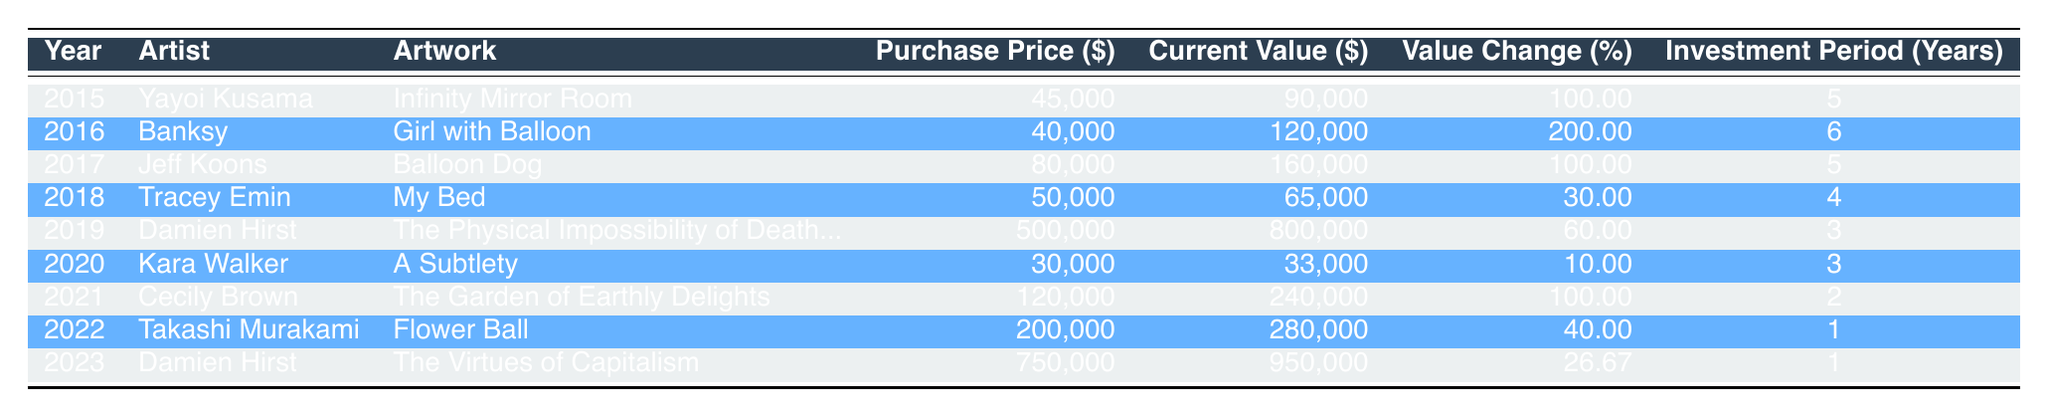What is the purchase price of the artwork "Infinity Mirror Room"? The table shows that the purchase price for "Infinity Mirror Room" by Yayoi Kusama in 2015 is 45,000. This can be found in the corresponding row under the "Purchase Price ($)" column.
Answer: 45,000 What is the current value of "Girl with Balloon"? According to the table, the current value of "Girl with Balloon" by Banksy in 2022 is 120,000. This information is in the "Current Value ($)" column under the appropriate row.
Answer: 120,000 Which artist had the highest value change percentage? By examining the "Value Change (%)" column, we can see that Banksy with "Girl with Balloon" has the highest value change percentage at 200.00%. This is determined by comparing all values in that column.
Answer: Banksy What is the average current value of artworks from 2015 to 2019? To calculate the average current value, we first find the current values from these years: 90,000 (Kusama) + 120,000 (Banksy) + 160,000 (Koons) + 65,000 (Emin) + 800,000 (Hirst) = 1,235,000. Then, we divide this sum by 5 (the number of artworks) to get 1,235,000 / 5 = 247,000.
Answer: 247,000 Did Cecily Brown's artwork double its purchase price? The purchase price of "The Garden of Earthly Delights" was 120,000 and the current value is 240,000. To check if it doubled, we see if 2 times 120,000 equals 240,000, which it does, indicating that it did double its purchase price.
Answer: Yes What is the total value change for Damien Hirst's artworks based on their current values from 2019 and 2023? The current values for Hirst's artworks are 800,000 (2019) and 950,000 (2023). The total value change is 950,000 - 800,000 = 150,000. This computation involves subtracting the earlier current value from the later one.
Answer: 150,000 Which artist had the lowest return on investment based on the value change percentage? By inspecting the "Value Change (%)" column, Kara Walker has the lowest at 10.00%. This can be found by comparing all value change percentages listed.
Answer: Kara Walker In which year was the artwork "My Bed" purchased? The table shows that "My Bed" by Tracey Emin was purchased in 2018. This is directly available in the "Year" column under Emin's artwork row.
Answer: 2018 What is the difference in purchase price between the most and least expensive artworks? The most expensive artwork is by Damien Hirst in 2019 with a purchase price of 500,000, and the least expensive is by Kara Walker in 2020 with a purchase price of 30,000. The difference is 500,000 - 30,000 = 470,000. Thus, we subtract the purchase price of the least expensive artwork from that of the most expensive.
Answer: 470,000 